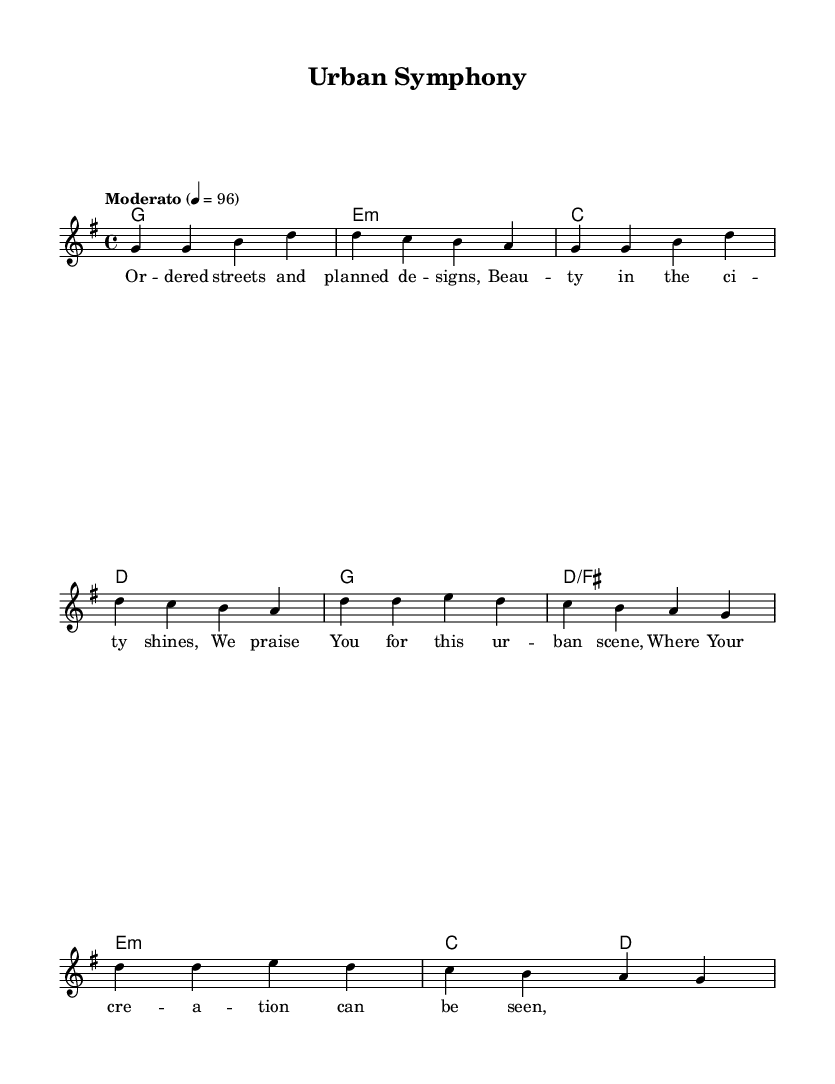What is the key signature of this music? The key signature is G major, which has one sharp (F sharp).
Answer: G major What is the time signature of this music? The time signature indicated at the beginning is four-four, meaning there are four beats in each measure.
Answer: 4/4 What is the tempo marking of the music? The tempo marking specifies "Moderato," which usually indicates a moderate pace (moderately fast), and the numerical marking of 4 = 96 indicates the beat per minute.
Answer: Moderato How many measures are in the verse? The verse consists of four measures, as represented by the four lines of music in the verse section.
Answer: 4 What is the first lyric phrase of the song? The first lyric phrase shown under the melody is "Or -- dered streets and planned de -- signs," which sets the thematic message of the worship song.
Answer: Or -- dered streets and planned de -- signs What do the lyrics suggest about the city? The lyrics suggest admiration and appreciation for the beauty and design of the city, as indicated by phrases like "ordered streets" and "beauty in the city shines."
Answer: Admiration Which chords are used in the chorus? The chorus uses the chords G major, D major over F sharp, E minor, and C major, followed by D major, as noted in the harmony section under the chorus.
Answer: G, D/F#, E minor, C, D 